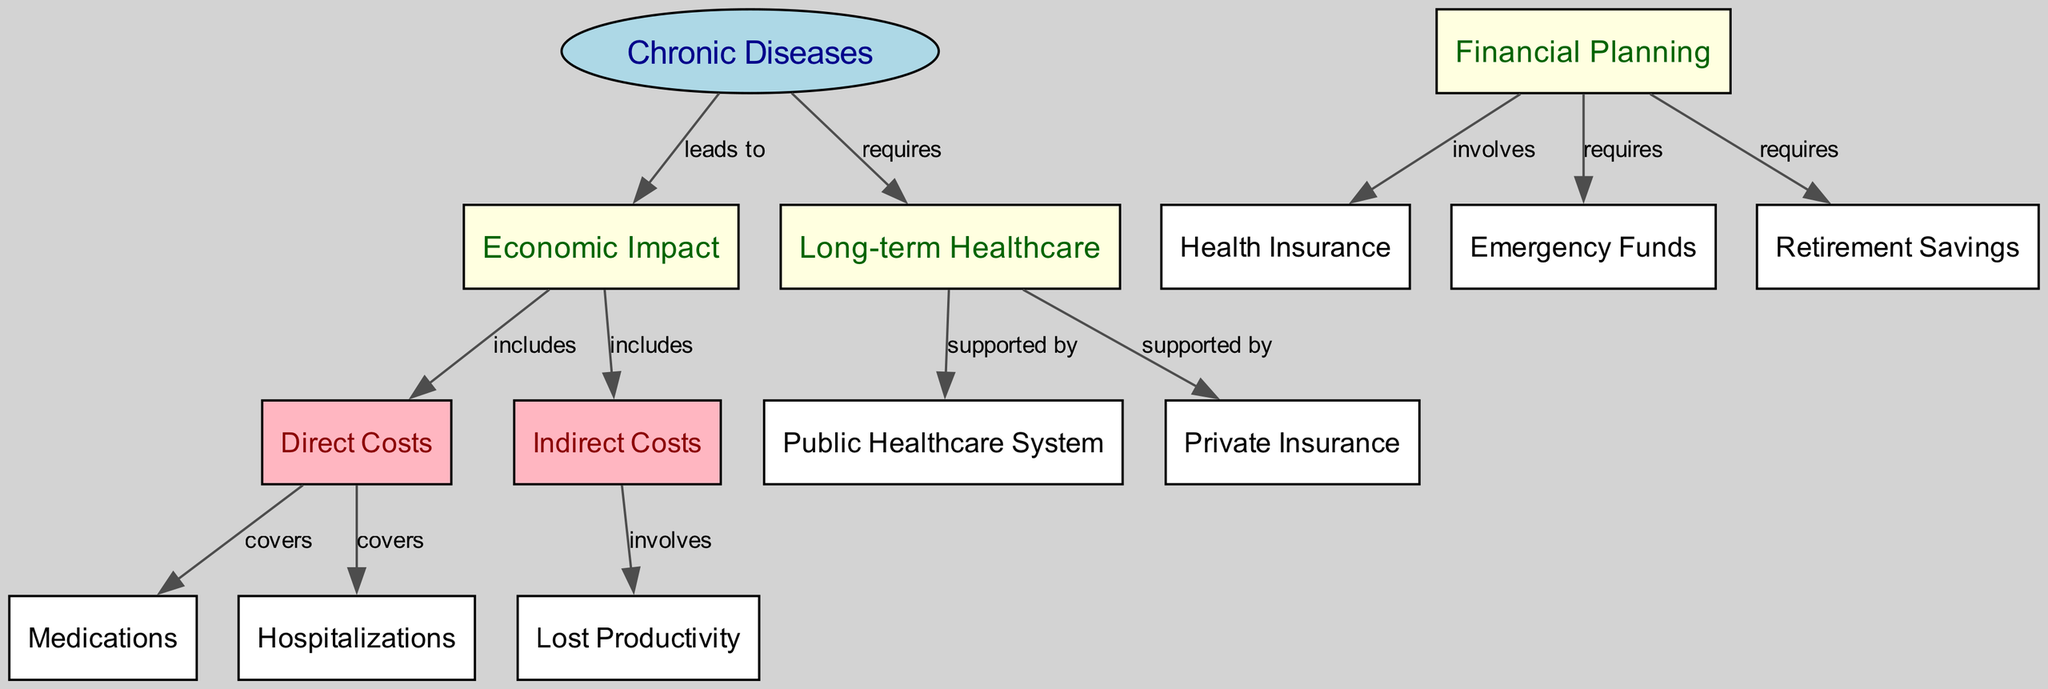What nodes are included in the diagram? The nodes listed in the diagram are Chronic Diseases, Economic Impact, Financial Planning, Long-term Healthcare, Direct Costs, Indirect Costs, Medications, Hospitalizations, Lost Productivity, Health Insurance, Emergency Funds, Retirement Savings, Public Healthcare System, and Private Insurance.
Answer: Chronic Diseases, Economic Impact, Financial Planning, Long-term Healthcare, Direct Costs, Indirect Costs, Medications, Hospitalizations, Lost Productivity, Health Insurance, Emergency Funds, Retirement Savings, Public Healthcare System, Private Insurance How many edges are present in the diagram? By counting the connections made between nodes, the diagram has a total of 12 edges connecting various nodes.
Answer: 12 What does Chronic Diseases lead to? According to the diagram, Chronic Diseases lead to Economic Impact and also require Long-term Healthcare.
Answer: Economic Impact and Long-term Healthcare What do Direct Costs cover? The diagram indicates that Direct Costs cover Medications and Hospitalizations.
Answer: Medications and Hospitalizations What does Financial Planning involve? The diagram shows that Financial Planning involves Health Insurance and requires both Emergency Funds and Retirement Savings.
Answer: Health Insurance, Emergency Funds, Retirement Savings What indirect costs are associated with Chronic Diseases? Indirect Costs involve Lost Productivity as highlighted in the diagram, indicating that this is a consequence of the economic impact of Chronic Diseases.
Answer: Lost Productivity How does Long-term Healthcare get supported? The diagram specifies that Long-term Healthcare is supported by the Public Healthcare System and Private Insurance, which are necessary for covering long-term expenses related to chronic diseases.
Answer: Public Healthcare System and Private Insurance What are the three main categories of economic impact associated with Chronic Diseases? The diagram illustrates that the economic impact includes Direct Costs, Indirect Costs, and it relates to the need for Financial Planning for Long-term Healthcare.
Answer: Direct Costs, Indirect Costs, Financial Planning How can someone financially prepare for Chronic Diseases according to this diagram? Financial preparation can involve acquiring Health Insurance, setting aside Emergency Funds, and building Retirement Savings, as indicated in the relationships connected to Financial Planning.
Answer: Health Insurance, Emergency Funds, Retirement Savings 